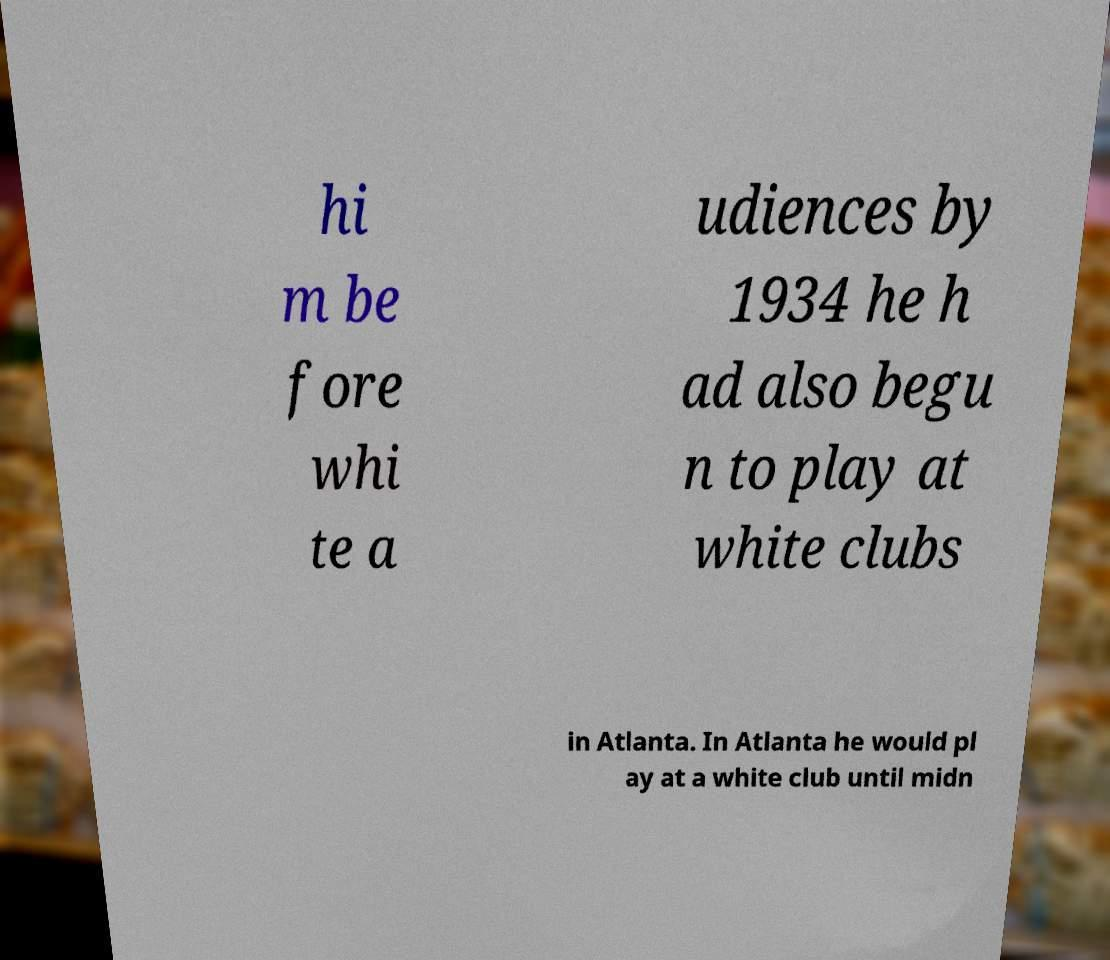I need the written content from this picture converted into text. Can you do that? hi m be fore whi te a udiences by 1934 he h ad also begu n to play at white clubs in Atlanta. In Atlanta he would pl ay at a white club until midn 